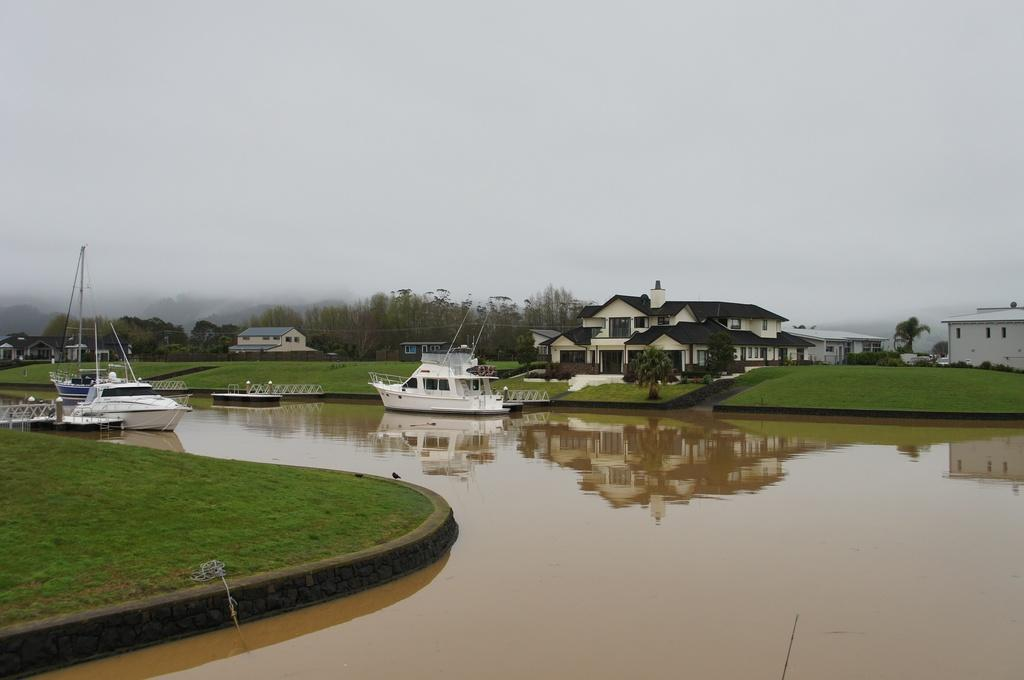What is in the water in the image? There are boats in the water in the image. What can be seen on the right side of the boats? There are houses, trees, grass, and the sky visible on the right side of the boats. How would you describe the natural environment on the right side of the boats? The natural environment includes trees and grass. What type of bead is being used to pave the road in the image? There is no road present in the image, so there are no beads being used for paving. 